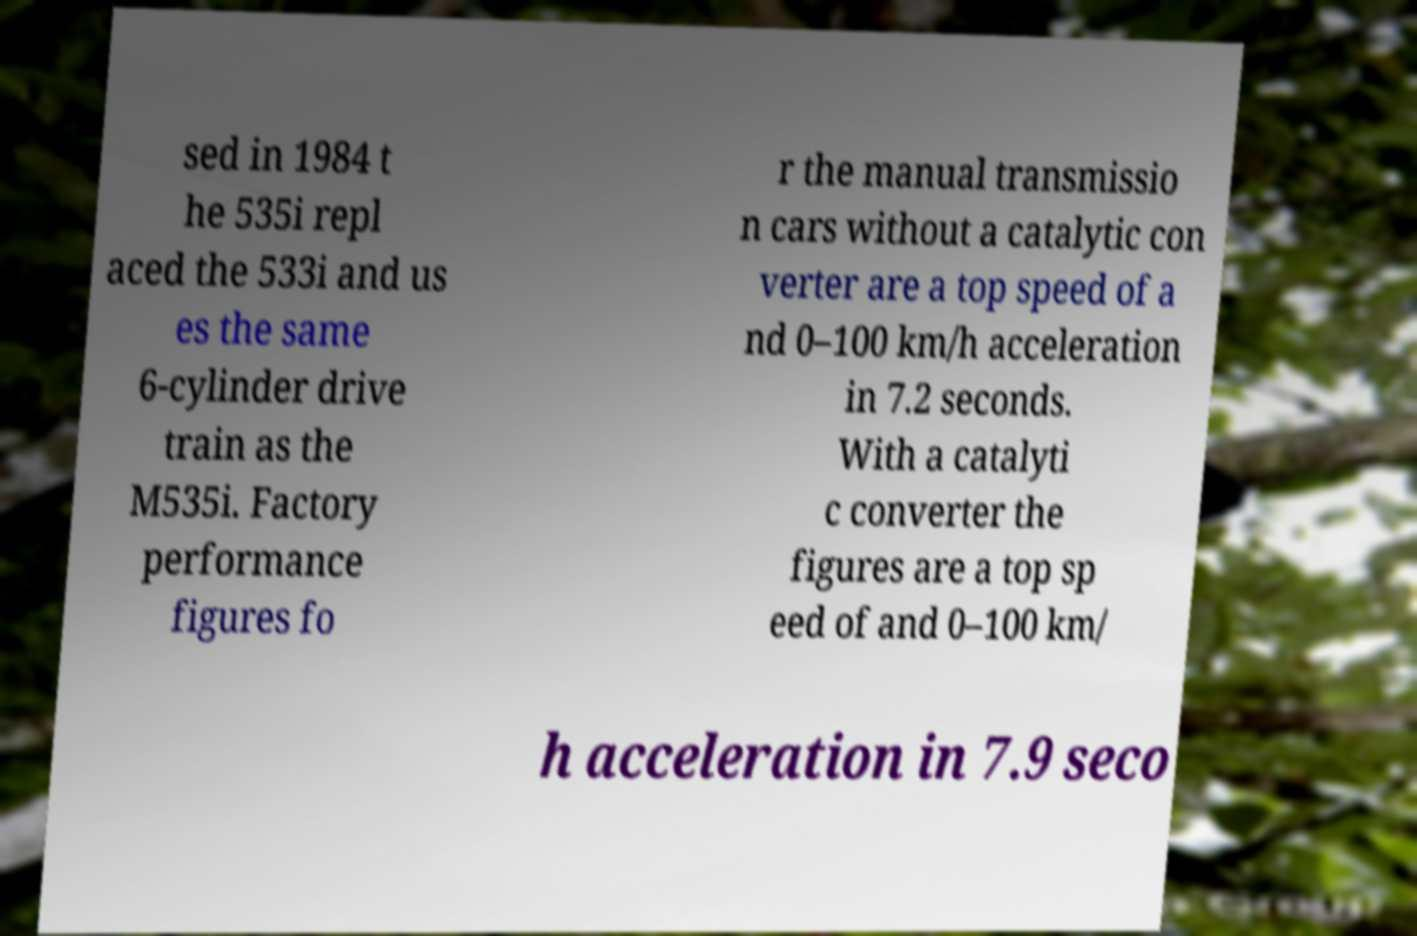Could you assist in decoding the text presented in this image and type it out clearly? sed in 1984 t he 535i repl aced the 533i and us es the same 6-cylinder drive train as the M535i. Factory performance figures fo r the manual transmissio n cars without a catalytic con verter are a top speed of a nd 0–100 km/h acceleration in 7.2 seconds. With a catalyti c converter the figures are a top sp eed of and 0–100 km/ h acceleration in 7.9 seco 